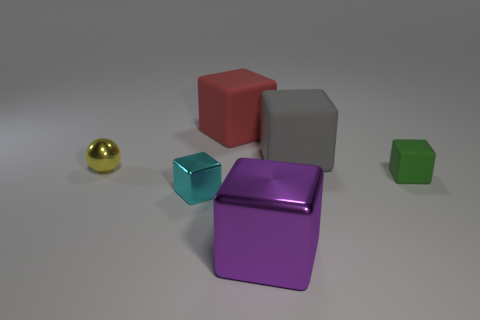How many blue objects are rubber things or small blocks?
Offer a terse response. 0. Are there any other yellow balls that have the same size as the metallic ball?
Your answer should be very brief. No. There is a purple block that is in front of the small object right of the shiny cube behind the big purple block; what is its material?
Make the answer very short. Metal. Is the number of small yellow things in front of the large purple thing the same as the number of large gray rubber blocks?
Give a very brief answer. No. Is the material of the green object to the right of the yellow thing the same as the big block that is in front of the tiny yellow metal ball?
Your response must be concise. No. How many objects are big gray metallic objects or matte things that are behind the gray rubber thing?
Offer a very short reply. 1. Are there any big cyan matte objects that have the same shape as the large gray rubber object?
Provide a succinct answer. No. How big is the cyan metallic thing that is right of the shiny object that is to the left of the tiny metal object that is to the right of the yellow metallic sphere?
Your answer should be very brief. Small. Are there the same number of big red blocks to the left of the purple object and tiny green things behind the tiny green matte cube?
Offer a very short reply. No. The purple cube that is the same material as the small yellow sphere is what size?
Give a very brief answer. Large. 